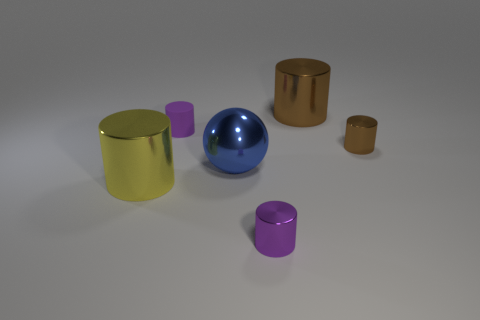How many other objects are the same color as the small rubber thing?
Make the answer very short. 1. Does the rubber thing have the same color as the small cylinder that is in front of the large yellow metal thing?
Give a very brief answer. Yes. How many green objects are large metallic things or metal cylinders?
Provide a short and direct response. 0. Are there the same number of purple matte cylinders that are in front of the big blue shiny ball and tiny matte balls?
Provide a succinct answer. Yes. What is the color of the other large metal thing that is the same shape as the big brown metallic object?
Your answer should be very brief. Yellow. What number of other brown metal things are the same shape as the tiny brown thing?
Give a very brief answer. 1. What material is the other small thing that is the same color as the small rubber thing?
Provide a short and direct response. Metal. What number of tiny brown cylinders are there?
Provide a short and direct response. 1. Are there any purple things that have the same material as the blue thing?
Your answer should be compact. Yes. There is a shiny thing that is the same color as the small matte thing; what is its size?
Offer a very short reply. Small. 